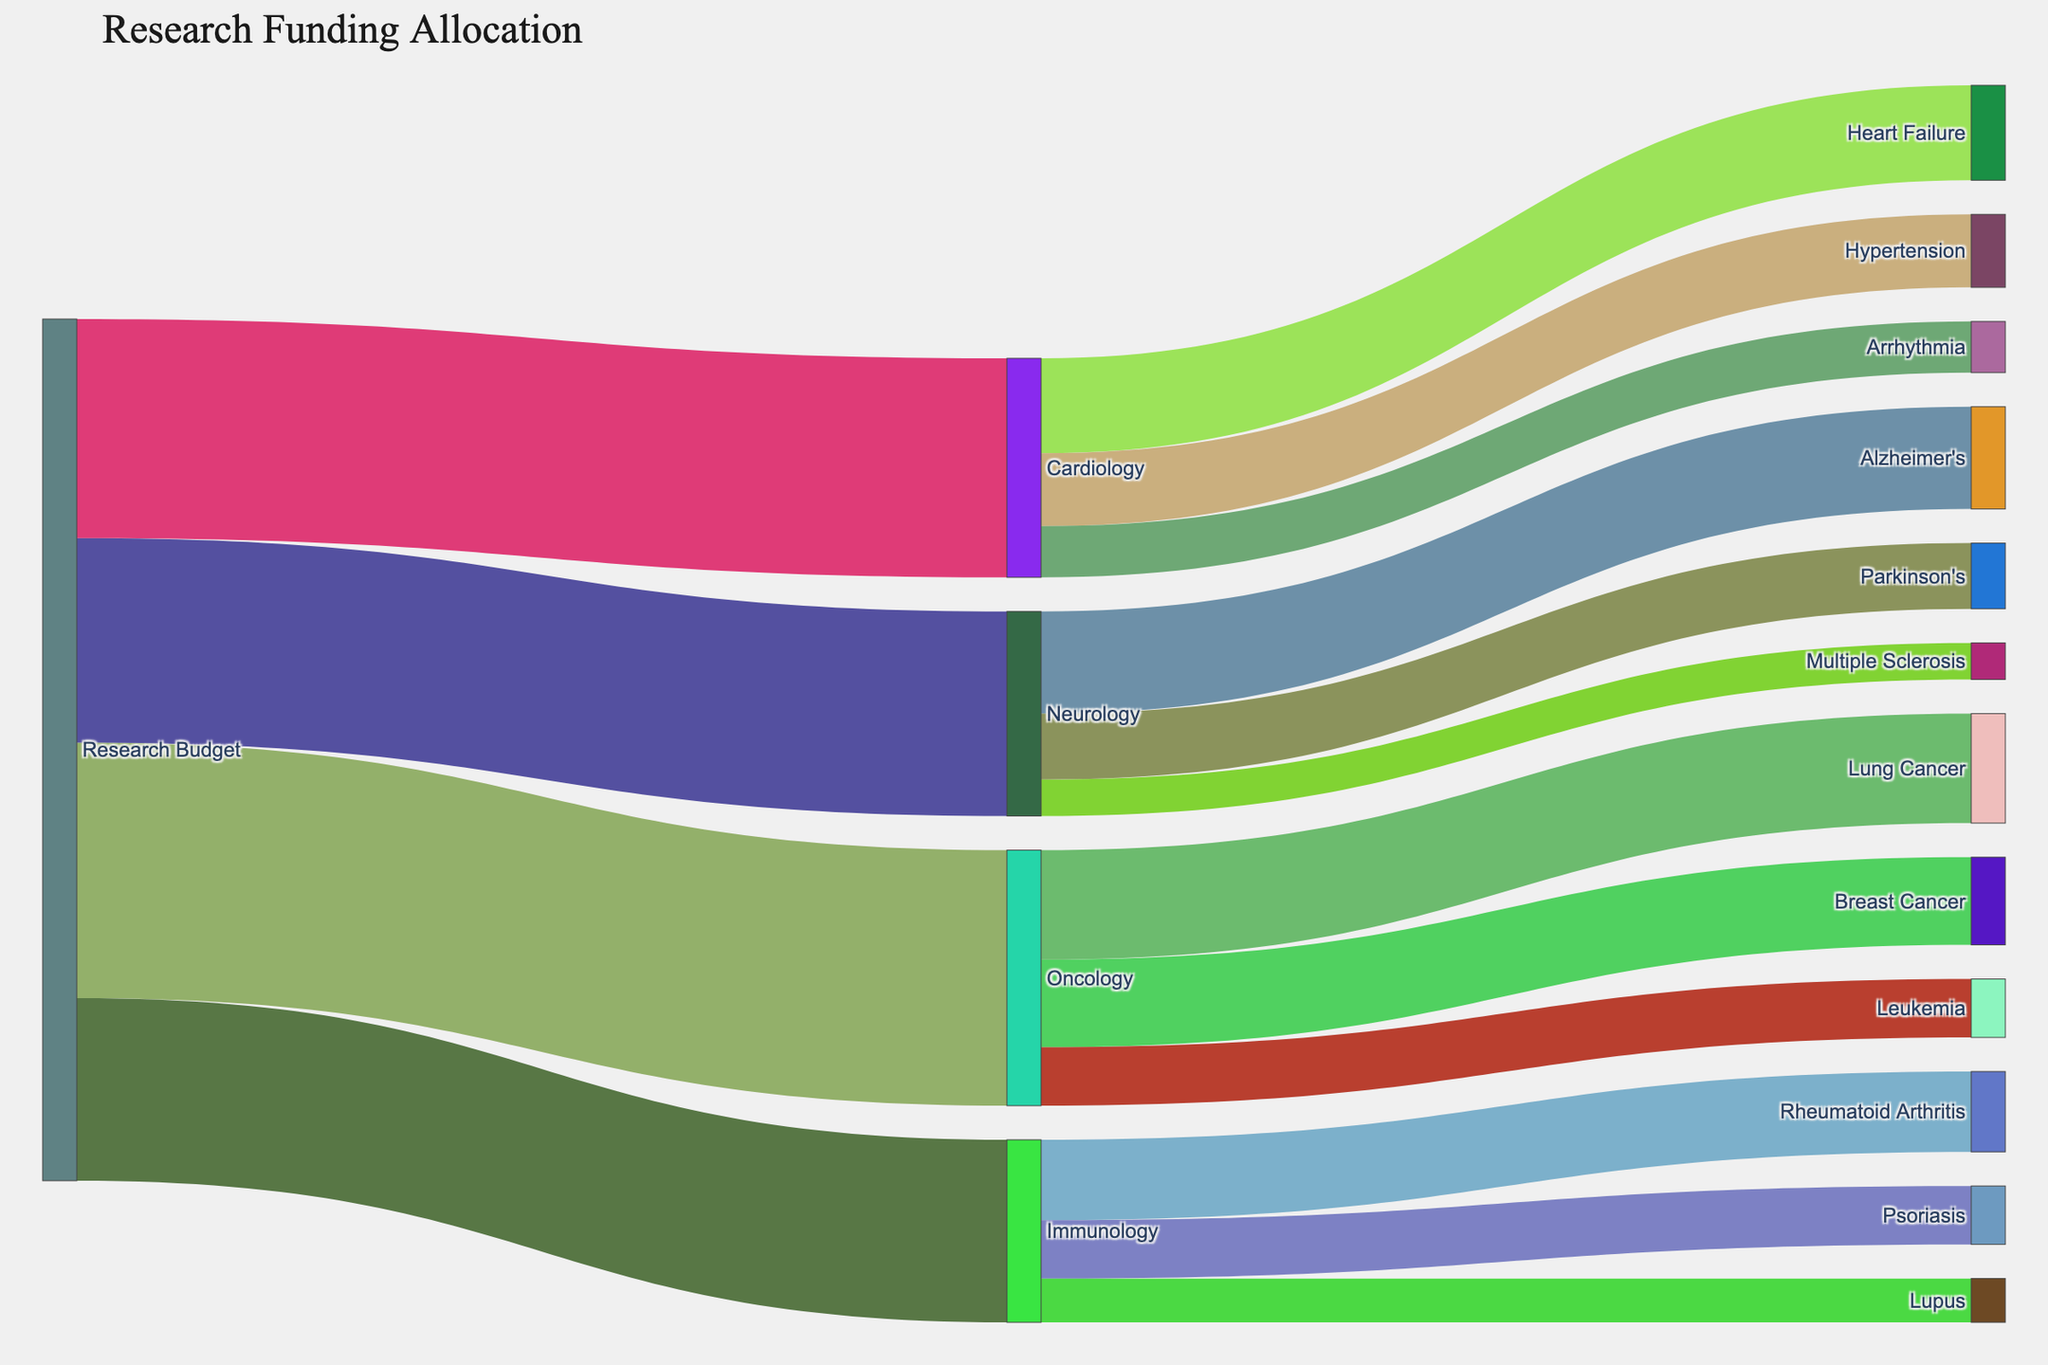What's the title of the figure? The title of the Sankey Diagram is usually displayed at the top of the figure.
Answer: Research Funding Allocation Which research area received the highest funding from the Research Budget? Start by locating the 'Research Budget' node, then follow its connections to the target nodes. The 'Oncology' target node shows the largest funding value of $35,000,000.
Answer: Oncology How much funding is allocated to Cardiovascular projects in total? Locate the 'Cardiology' node and sum the values of its connected target nodes: Heart Failure ($13,000,000), Hypertension ($10,000,000), and Arrhythmia ($7,000,000). The total is $13,000,000 + $10,000,000 + $7,000,000 = $30,000,000.
Answer: $30,000,000 Compare the funding between Alzheimer's and Leukemia projects. Which one received more, and by how much? Find the 'Alzheimer's' node under 'Neurology' ($14,000,000) and the 'Leukemia' node under 'Oncology' ($8,000,000). Subtract the values to find the difference: $14,000,000 - $8,000,000 = $6,000,000. Alzheimer's received more by $6,000,000.
Answer: Alzheimer's received more by $6,000,000 How does the funding for Breast Cancer compare to Parkinson's Disease? Locate the 'Breast Cancer' node under 'Oncology' ($12,000,000) and the 'Parkinson's' node under 'Neurology' ($9,000,000). Compare the values to see that Breast Cancer received $3,000,000 more.
Answer: Breast Cancer received $3,000,000 more What is the combined funding for Immunology projects? Locate the 'Immunology' node and sum the funding for all its connected target projects: Rheumatoid Arthritis ($11,000,000), Psoriasis ($8,000,000), and Lupus ($6,000,000). The combined total is $11,000,000 + $8,000,000 + $6,000,000 = $25,000,000.
Answer: $25,000,000 Which project received the least amount of funding, and how much? Identify the project nodes with the smallest values. 'Multiple Sclerosis' under 'Neurology' received the lowest funding value of $5,000,000.
Answer: Multiple Sclerosis, $5,000,000 What's the total amount of funding allocated to Neurology projects? Locate the 'Neurology' node and sum the funding for all its connected target projects: Alzheimer's ($14,000,000), Parkinson's ($9,000,000), and Multiple Sclerosis ($5,000,000). The total is $14,000,000 + $9,000,000 + $5,000,000 = $28,000,000.
Answer: $28,000,000 